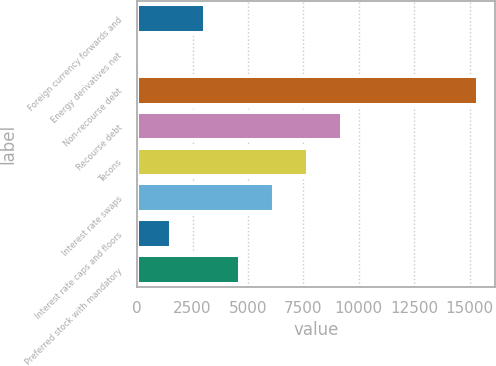Convert chart. <chart><loc_0><loc_0><loc_500><loc_500><bar_chart><fcel>Foreign currency forwards and<fcel>Energy derivatives net<fcel>Non-recourse debt<fcel>Recourse debt<fcel>Tecons<fcel>Interest rate swaps<fcel>Interest rate caps and floors<fcel>Preferred stock with mandatory<nl><fcel>3078.4<fcel>2<fcel>15384<fcel>9231.2<fcel>7693<fcel>6154.8<fcel>1540.2<fcel>4616.6<nl></chart> 